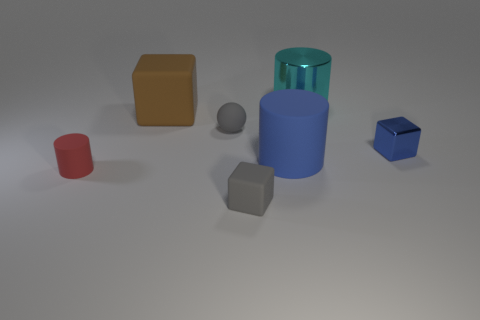What is the material of the blue object that is the same shape as the big cyan metal object?
Provide a short and direct response. Rubber. There is a large cyan shiny cylinder that is to the right of the big matte object that is to the right of the gray block; how many gray matte blocks are in front of it?
Make the answer very short. 1. Is there anything else of the same color as the small cylinder?
Provide a succinct answer. No. What number of cylinders are both on the left side of the large cyan thing and to the right of the big brown thing?
Your answer should be very brief. 1. Do the shiny thing in front of the big block and the cylinder left of the small rubber ball have the same size?
Your answer should be compact. Yes. How many objects are either objects that are in front of the brown thing or yellow objects?
Your answer should be compact. 5. What material is the gray thing in front of the small cylinder?
Offer a very short reply. Rubber. What is the material of the big cyan thing?
Provide a short and direct response. Metal. The block right of the tiny gray thing that is in front of the blue thing left of the cyan cylinder is made of what material?
Your answer should be compact. Metal. Is there any other thing that has the same material as the small ball?
Provide a short and direct response. Yes. 